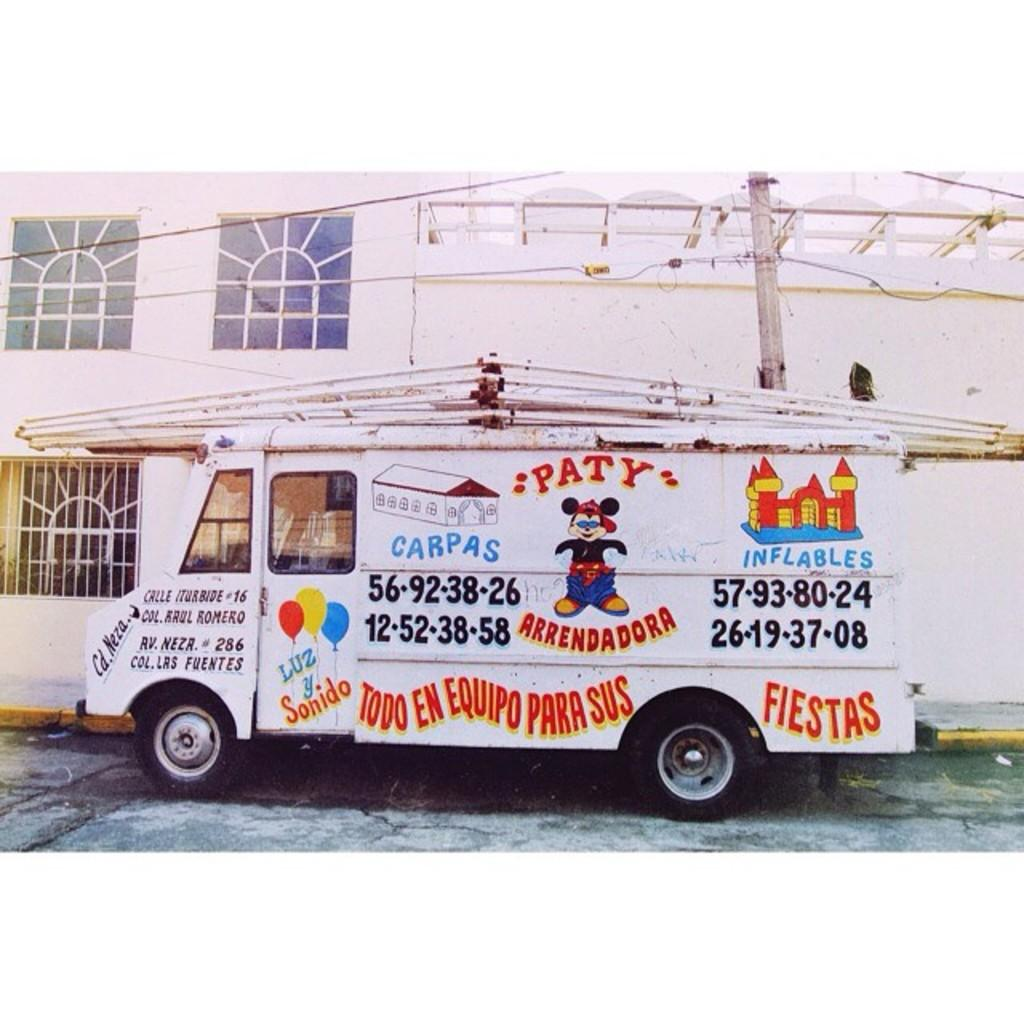<image>
Create a compact narrative representing the image presented. A van next a building advertising Party supplies such as inflatable castles and balloons. 